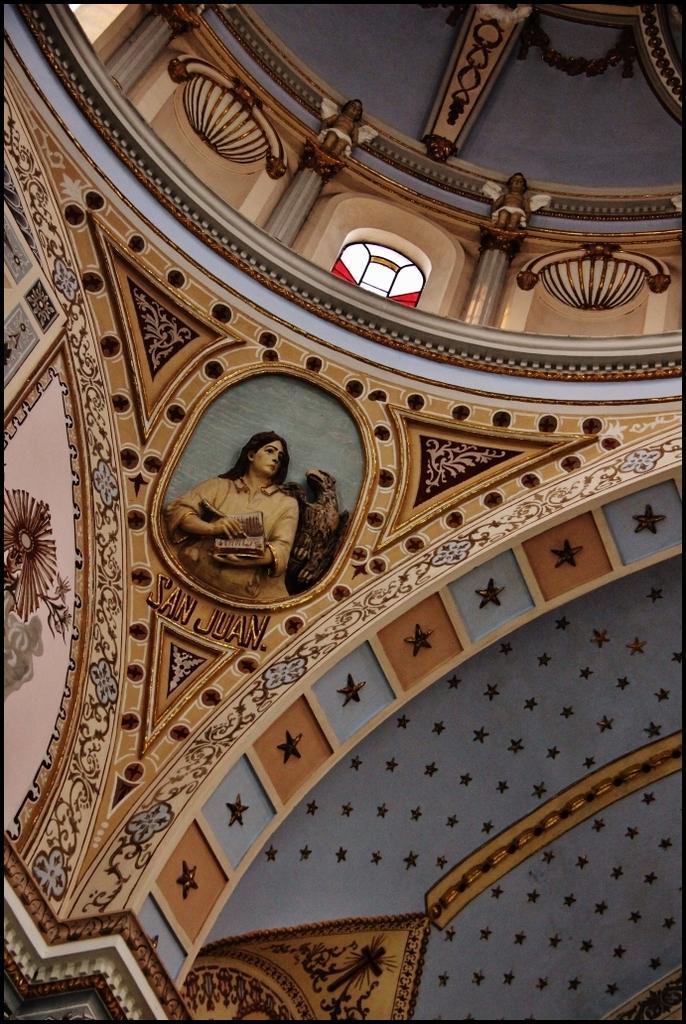Describe this image in one or two sentences. In this image there might be a wall, and on the wall there is some art. And at the top of the image there is window and some objects on the wall. 